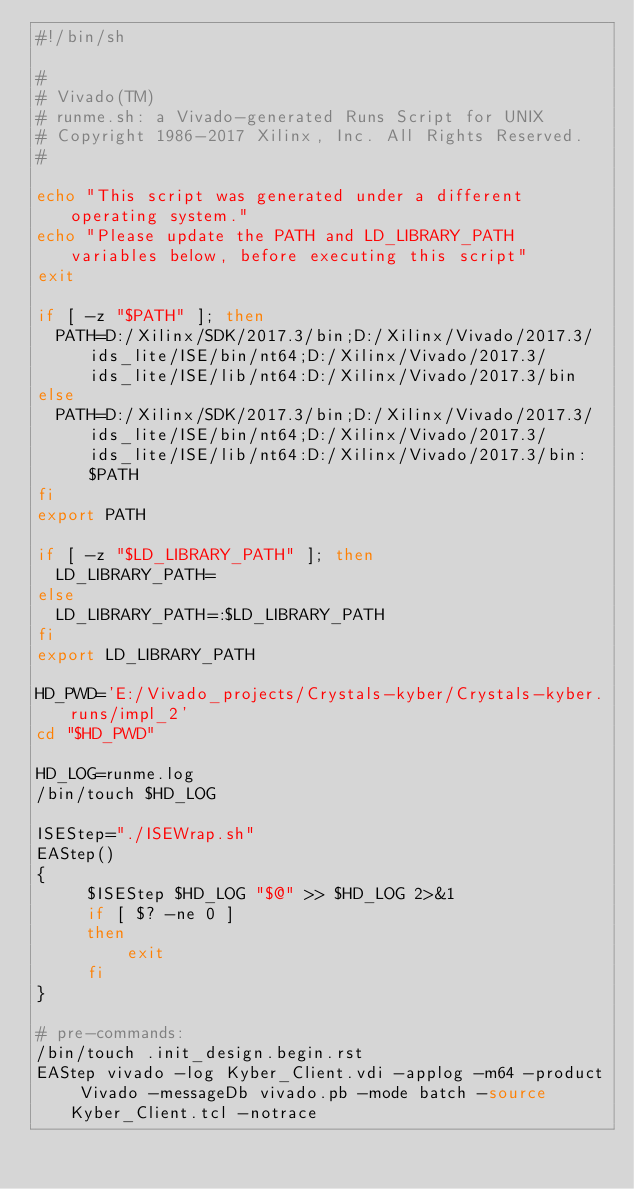<code> <loc_0><loc_0><loc_500><loc_500><_Bash_>#!/bin/sh

# 
# Vivado(TM)
# runme.sh: a Vivado-generated Runs Script for UNIX
# Copyright 1986-2017 Xilinx, Inc. All Rights Reserved.
# 

echo "This script was generated under a different operating system."
echo "Please update the PATH and LD_LIBRARY_PATH variables below, before executing this script"
exit

if [ -z "$PATH" ]; then
  PATH=D:/Xilinx/SDK/2017.3/bin;D:/Xilinx/Vivado/2017.3/ids_lite/ISE/bin/nt64;D:/Xilinx/Vivado/2017.3/ids_lite/ISE/lib/nt64:D:/Xilinx/Vivado/2017.3/bin
else
  PATH=D:/Xilinx/SDK/2017.3/bin;D:/Xilinx/Vivado/2017.3/ids_lite/ISE/bin/nt64;D:/Xilinx/Vivado/2017.3/ids_lite/ISE/lib/nt64:D:/Xilinx/Vivado/2017.3/bin:$PATH
fi
export PATH

if [ -z "$LD_LIBRARY_PATH" ]; then
  LD_LIBRARY_PATH=
else
  LD_LIBRARY_PATH=:$LD_LIBRARY_PATH
fi
export LD_LIBRARY_PATH

HD_PWD='E:/Vivado_projects/Crystals-kyber/Crystals-kyber.runs/impl_2'
cd "$HD_PWD"

HD_LOG=runme.log
/bin/touch $HD_LOG

ISEStep="./ISEWrap.sh"
EAStep()
{
     $ISEStep $HD_LOG "$@" >> $HD_LOG 2>&1
     if [ $? -ne 0 ]
     then
         exit
     fi
}

# pre-commands:
/bin/touch .init_design.begin.rst
EAStep vivado -log Kyber_Client.vdi -applog -m64 -product Vivado -messageDb vivado.pb -mode batch -source Kyber_Client.tcl -notrace


</code> 